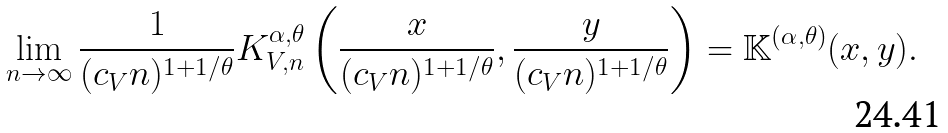<formula> <loc_0><loc_0><loc_500><loc_500>\lim _ { n \to \infty } \frac { 1 } { ( c _ { V } n ) ^ { 1 + 1 / \theta } } K ^ { \alpha , \theta } _ { V , n } \left ( \frac { x } { ( c _ { V } n ) ^ { 1 + 1 / \theta } } , \frac { y } { ( c _ { V } n ) ^ { 1 + 1 / \theta } } \right ) = \mathbb { K } ^ { ( \alpha , \theta ) } ( x , y ) .</formula> 